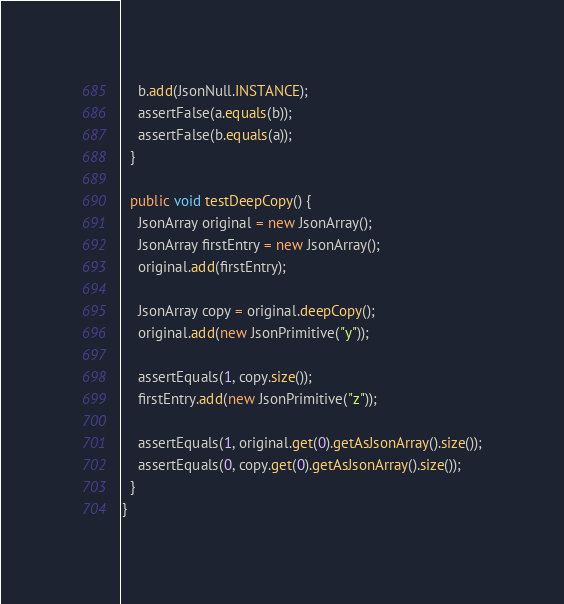Convert code to text. <code><loc_0><loc_0><loc_500><loc_500><_Java_>    b.add(JsonNull.INSTANCE);
    assertFalse(a.equals(b));
    assertFalse(b.equals(a));
  }

  public void testDeepCopy() {
    JsonArray original = new JsonArray();
    JsonArray firstEntry = new JsonArray();
    original.add(firstEntry);

    JsonArray copy = original.deepCopy();
    original.add(new JsonPrimitive("y"));

    assertEquals(1, copy.size());
    firstEntry.add(new JsonPrimitive("z"));

    assertEquals(1, original.get(0).getAsJsonArray().size());
    assertEquals(0, copy.get(0).getAsJsonArray().size());
  }
}
</code> 